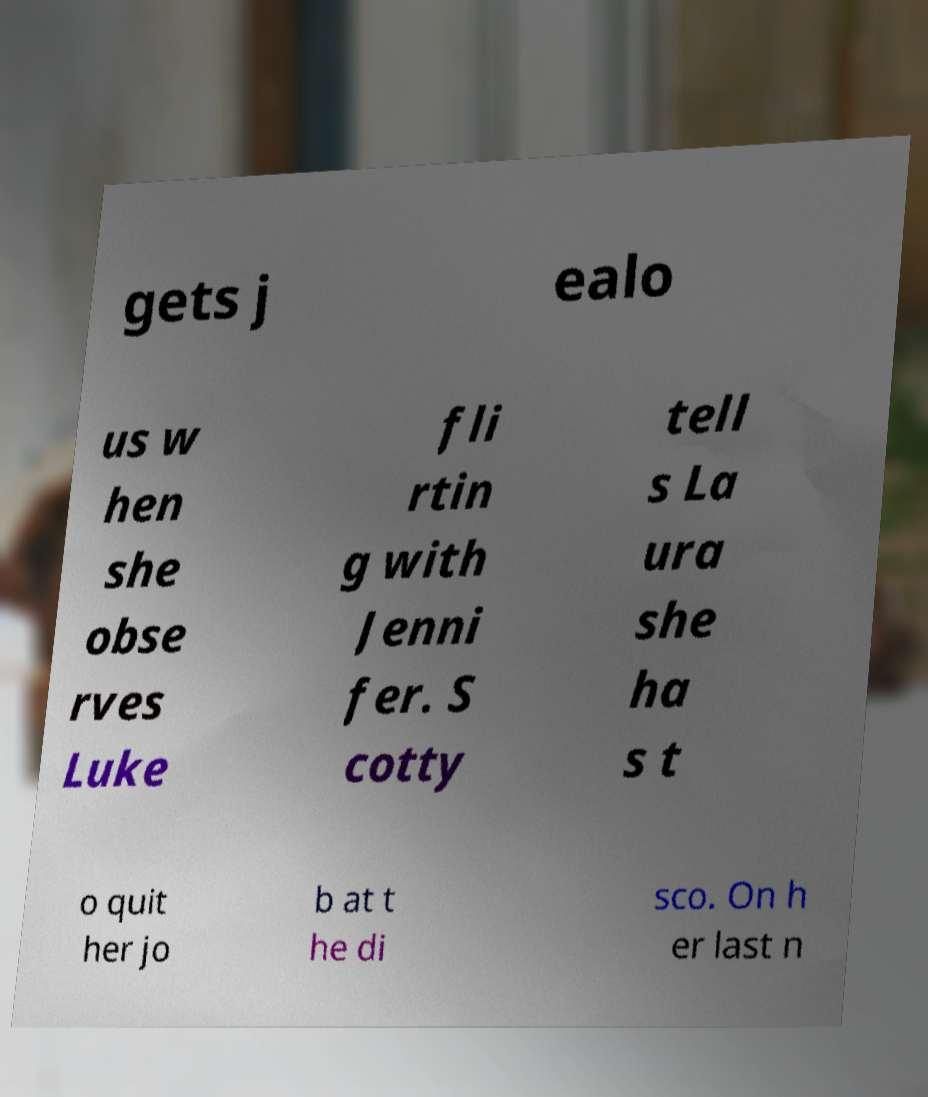What messages or text are displayed in this image? I need them in a readable, typed format. gets j ealo us w hen she obse rves Luke fli rtin g with Jenni fer. S cotty tell s La ura she ha s t o quit her jo b at t he di sco. On h er last n 